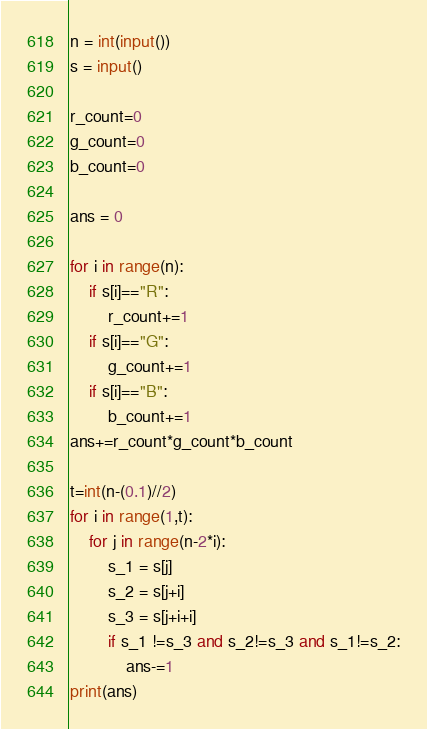Convert code to text. <code><loc_0><loc_0><loc_500><loc_500><_Python_>n = int(input())
s = input()

r_count=0
g_count=0
b_count=0

ans = 0

for i in range(n):
    if s[i]=="R":
        r_count+=1
    if s[i]=="G":
        g_count+=1
    if s[i]=="B":
        b_count+=1
ans+=r_count*g_count*b_count

t=int(n-(0.1)//2)
for i in range(1,t):
    for j in range(n-2*i):
        s_1 = s[j]
        s_2 = s[j+i]
        s_3 = s[j+i+i]
        if s_1 !=s_3 and s_2!=s_3 and s_1!=s_2:
            ans-=1
print(ans) </code> 